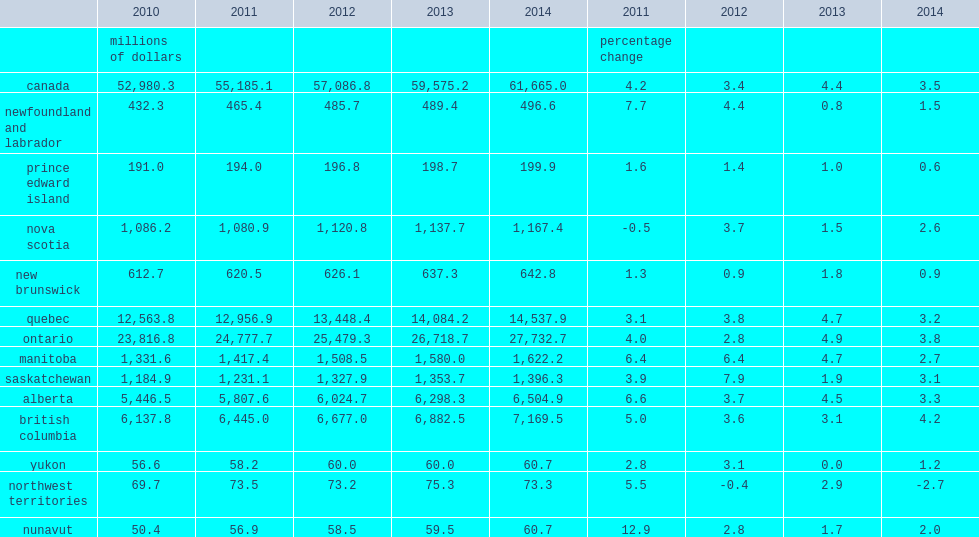What was the percentage change of gdp of culture industries nationally in 2014? 3.5. What was the percentage change of gdp of culture industries nationally in 2013? 4.4. What was the percent of gdp of culture industries increased in all provinces and territories except northwest territories? -2.7. What the percent of growth did british columbia have in 2014? 4.2. What the percent of growth did ontario have in 2014? 3.8. What the percent of growth did alberta have in 2014? 3.3. How many percentage points did gdp of culture industries in prince edward island grow in 2014? 0.6. How many percentage points did gdp of culture industries in prince edward island grow in 2013? 1.0. How many percentage points did gdp of culture industries in nova scotia grow in 2014? 2.6. How many percentage points did gdp of culture industries in nova scotia increase in 2013? 1.5. How many percentage points did gdp of culture industries in new brunswick grow in 2014? 0.9. How many percentage points did gdp of culture industries in ontario advance in 2014? 3.8. How many percentage points did gdp of culture industries in ontario increase in 2013? 4.9. How many percentage points did gdp of culture industries in manitoba grow in 2014? 2.7. How many percentage points did gdp of culture industries in manitoba grow in 2013? 4.7. How many percentage points did gdp of culture industries in saskatchewan advance in 2014? 3.1. How many percentage points did gdp of culture industries in saskatchewan increase in 2013? 1.9. How many percentage points did gdp of culture industries in alberta grow in 2014? 3.3. How many percentage points did gdp of culture industries in alberta grow in 2013? 4.5. How many percentage points did gdp of culture industries in british columbia rise in 2014? 4.2. How many percentage points did gdp of culture industries in british columbia rise in 2013? 3.1. How many percentage points did gdp of culture industries in yukon grow in 2014? 1.2. How many percentage points did gdp of culture industries in yukon grow in 2013? 0.0. How many percentage points did gdp of culture industries in northwest territories fall in 2014? 2.7. How many percentage points did gdp of culture industries in northwest territories advance in 2013? 2.9. How many percentage points did nunavut's gdp of culture industries advance in 2014? 2.0. How many percentage points did nunavut's gdp of culture industries increase in 2013? 1.7. 